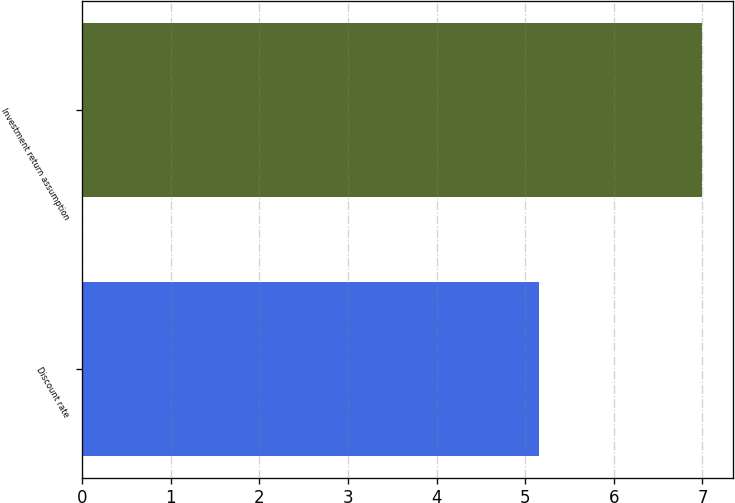Convert chart. <chart><loc_0><loc_0><loc_500><loc_500><bar_chart><fcel>Discount rate<fcel>Investment return assumption<nl><fcel>5.15<fcel>7<nl></chart> 